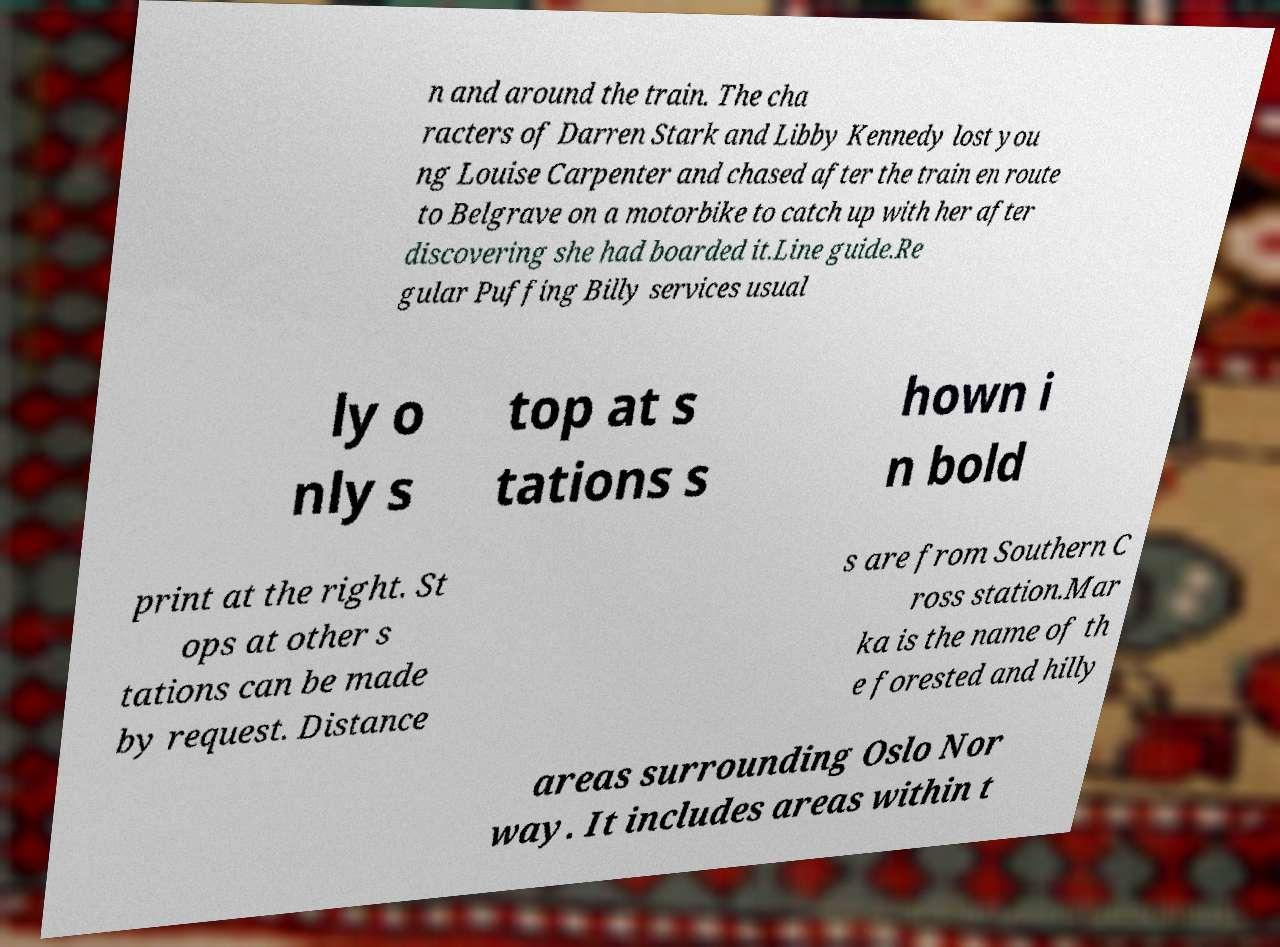Please read and relay the text visible in this image. What does it say? n and around the train. The cha racters of Darren Stark and Libby Kennedy lost you ng Louise Carpenter and chased after the train en route to Belgrave on a motorbike to catch up with her after discovering she had boarded it.Line guide.Re gular Puffing Billy services usual ly o nly s top at s tations s hown i n bold print at the right. St ops at other s tations can be made by request. Distance s are from Southern C ross station.Mar ka is the name of th e forested and hilly areas surrounding Oslo Nor way. It includes areas within t 